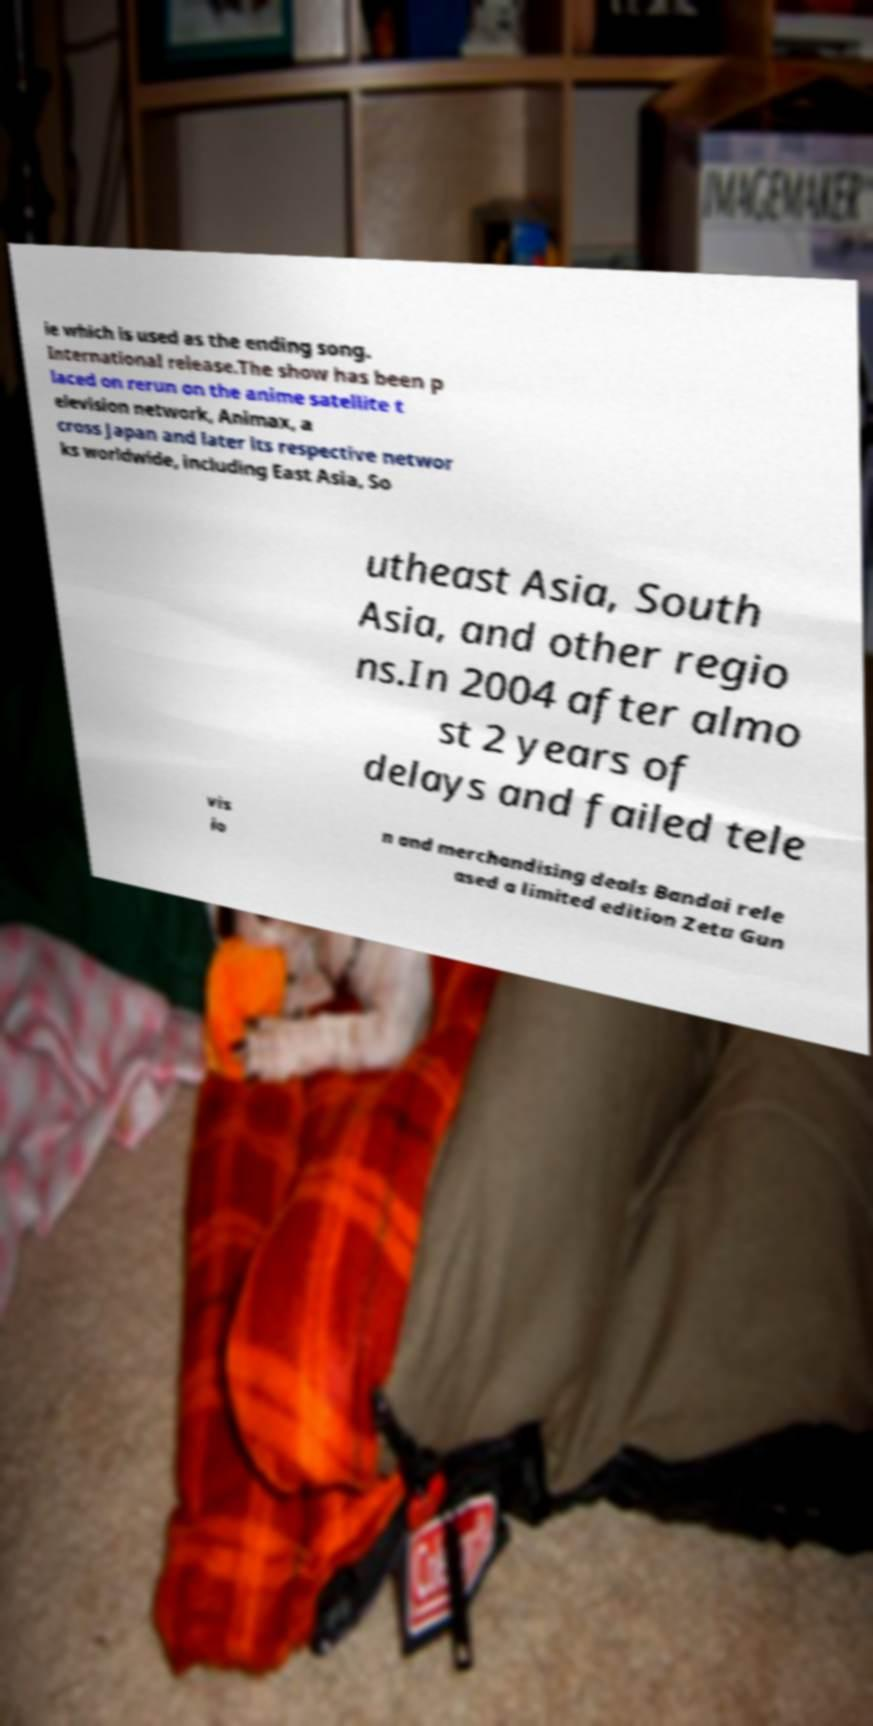There's text embedded in this image that I need extracted. Can you transcribe it verbatim? ie which is used as the ending song. International release.The show has been p laced on rerun on the anime satellite t elevision network, Animax, a cross Japan and later its respective networ ks worldwide, including East Asia, So utheast Asia, South Asia, and other regio ns.In 2004 after almo st 2 years of delays and failed tele vis io n and merchandising deals Bandai rele ased a limited edition Zeta Gun 